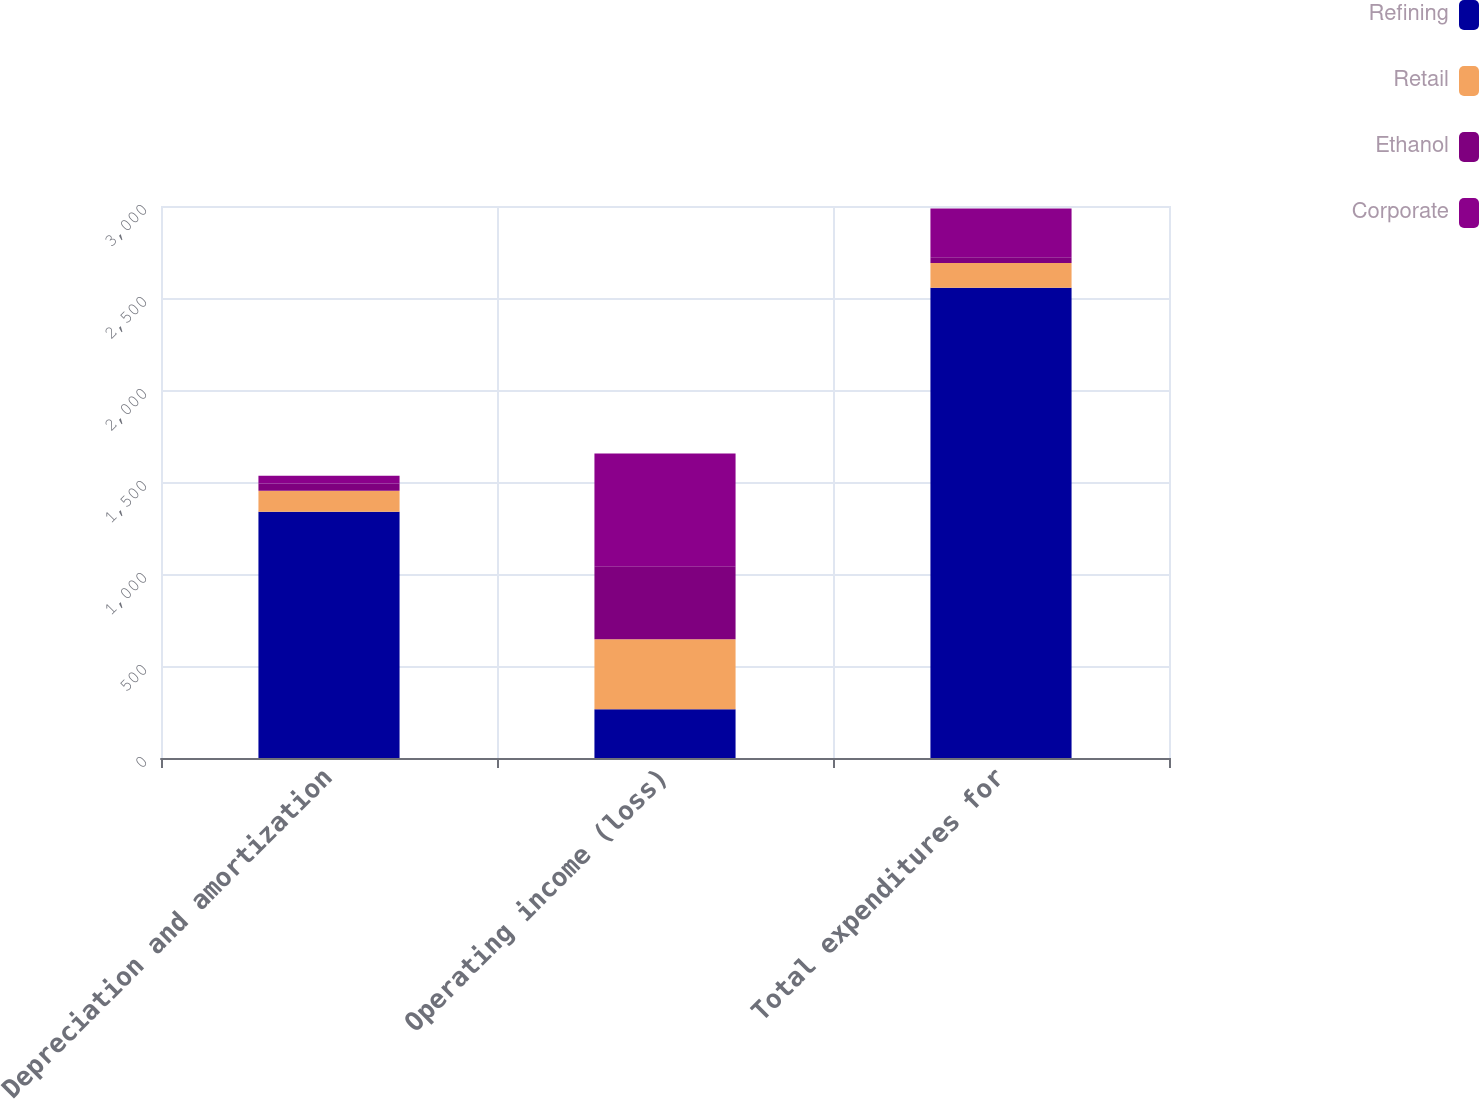<chart> <loc_0><loc_0><loc_500><loc_500><stacked_bar_chart><ecel><fcel>Depreciation and amortization<fcel>Operating income (loss)<fcel>Total expenditures for<nl><fcel>Refining<fcel>1338<fcel>265<fcel>2556<nl><fcel>Retail<fcel>115<fcel>381<fcel>134<nl><fcel>Ethanol<fcel>39<fcel>396<fcel>32<nl><fcel>Corporate<fcel>42<fcel>613<fcel>265<nl></chart> 